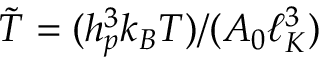<formula> <loc_0><loc_0><loc_500><loc_500>\tilde { T } = ( h _ { p } ^ { 3 } k _ { B } T ) / ( A _ { 0 } \ell _ { K } ^ { 3 } )</formula> 